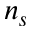Convert formula to latex. <formula><loc_0><loc_0><loc_500><loc_500>n _ { s }</formula> 